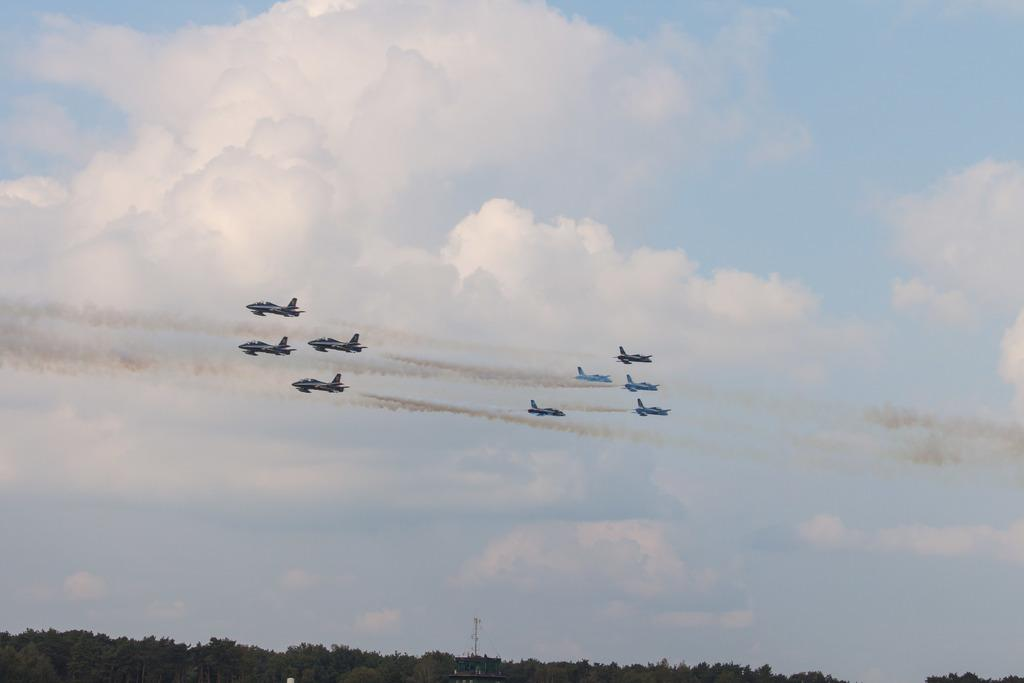What is happening in the sky in the image? There are aeroplanes flying in the air in the image. Where are the aeroplanes located in the image? The aeroplanes are in the sky in the image. What can be seen at the bottom of the image? There are trees at the bottom of the image. How many pins can be seen attached to the aeroplanes in the image? There are no pins visible on the aeroplanes in the image. What type of fangs can be seen on the trees in the image? There are no fangs present on the trees in the image; they are simply trees. 